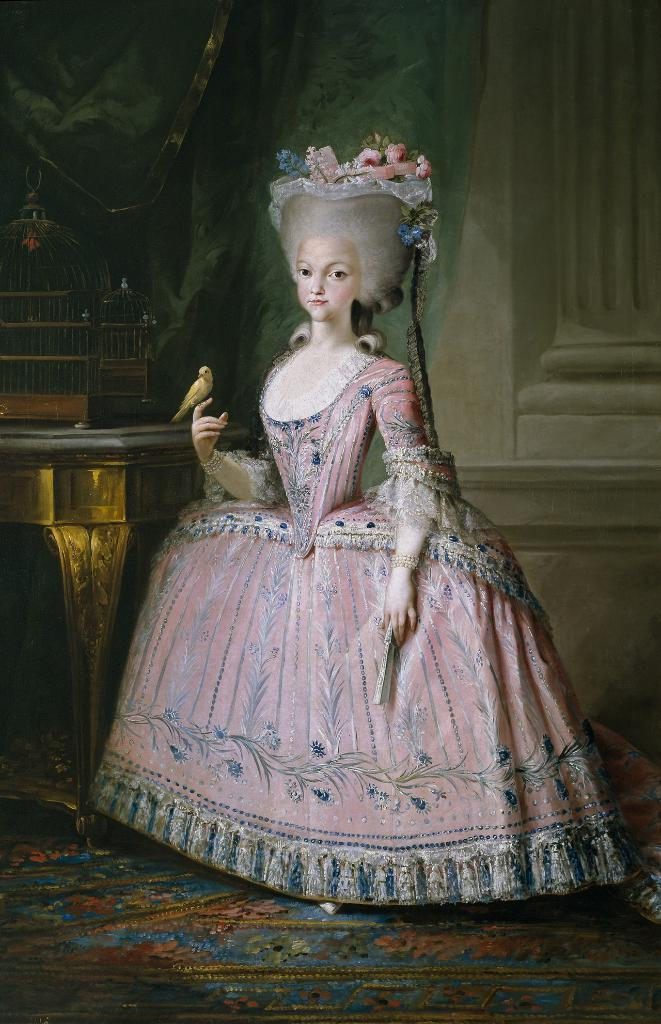Who is the main subject in the image? There is a woman in the image. What is the woman wearing? The woman is wearing a pink dress. Where is the woman positioned in the image? The woman is standing in the front. What can be seen in the background of the image? There is a wall, a curtain, a table, and a rack full of books in the background of the image. What type of zebra can be seen teaching the woman in the image? There is no zebra present in the image, and the woman is not being taught by anyone. 